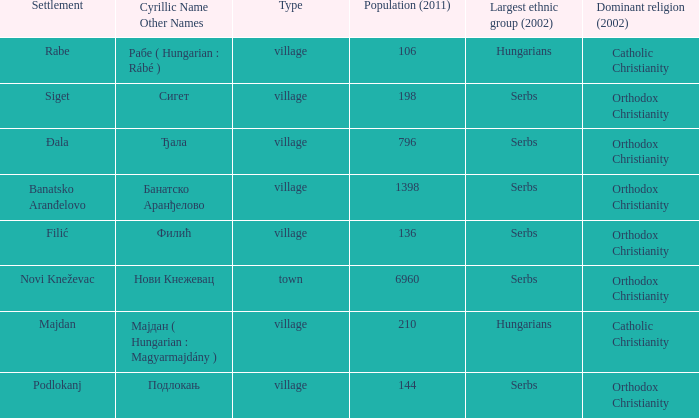What type of settlement is rabe? Village. 